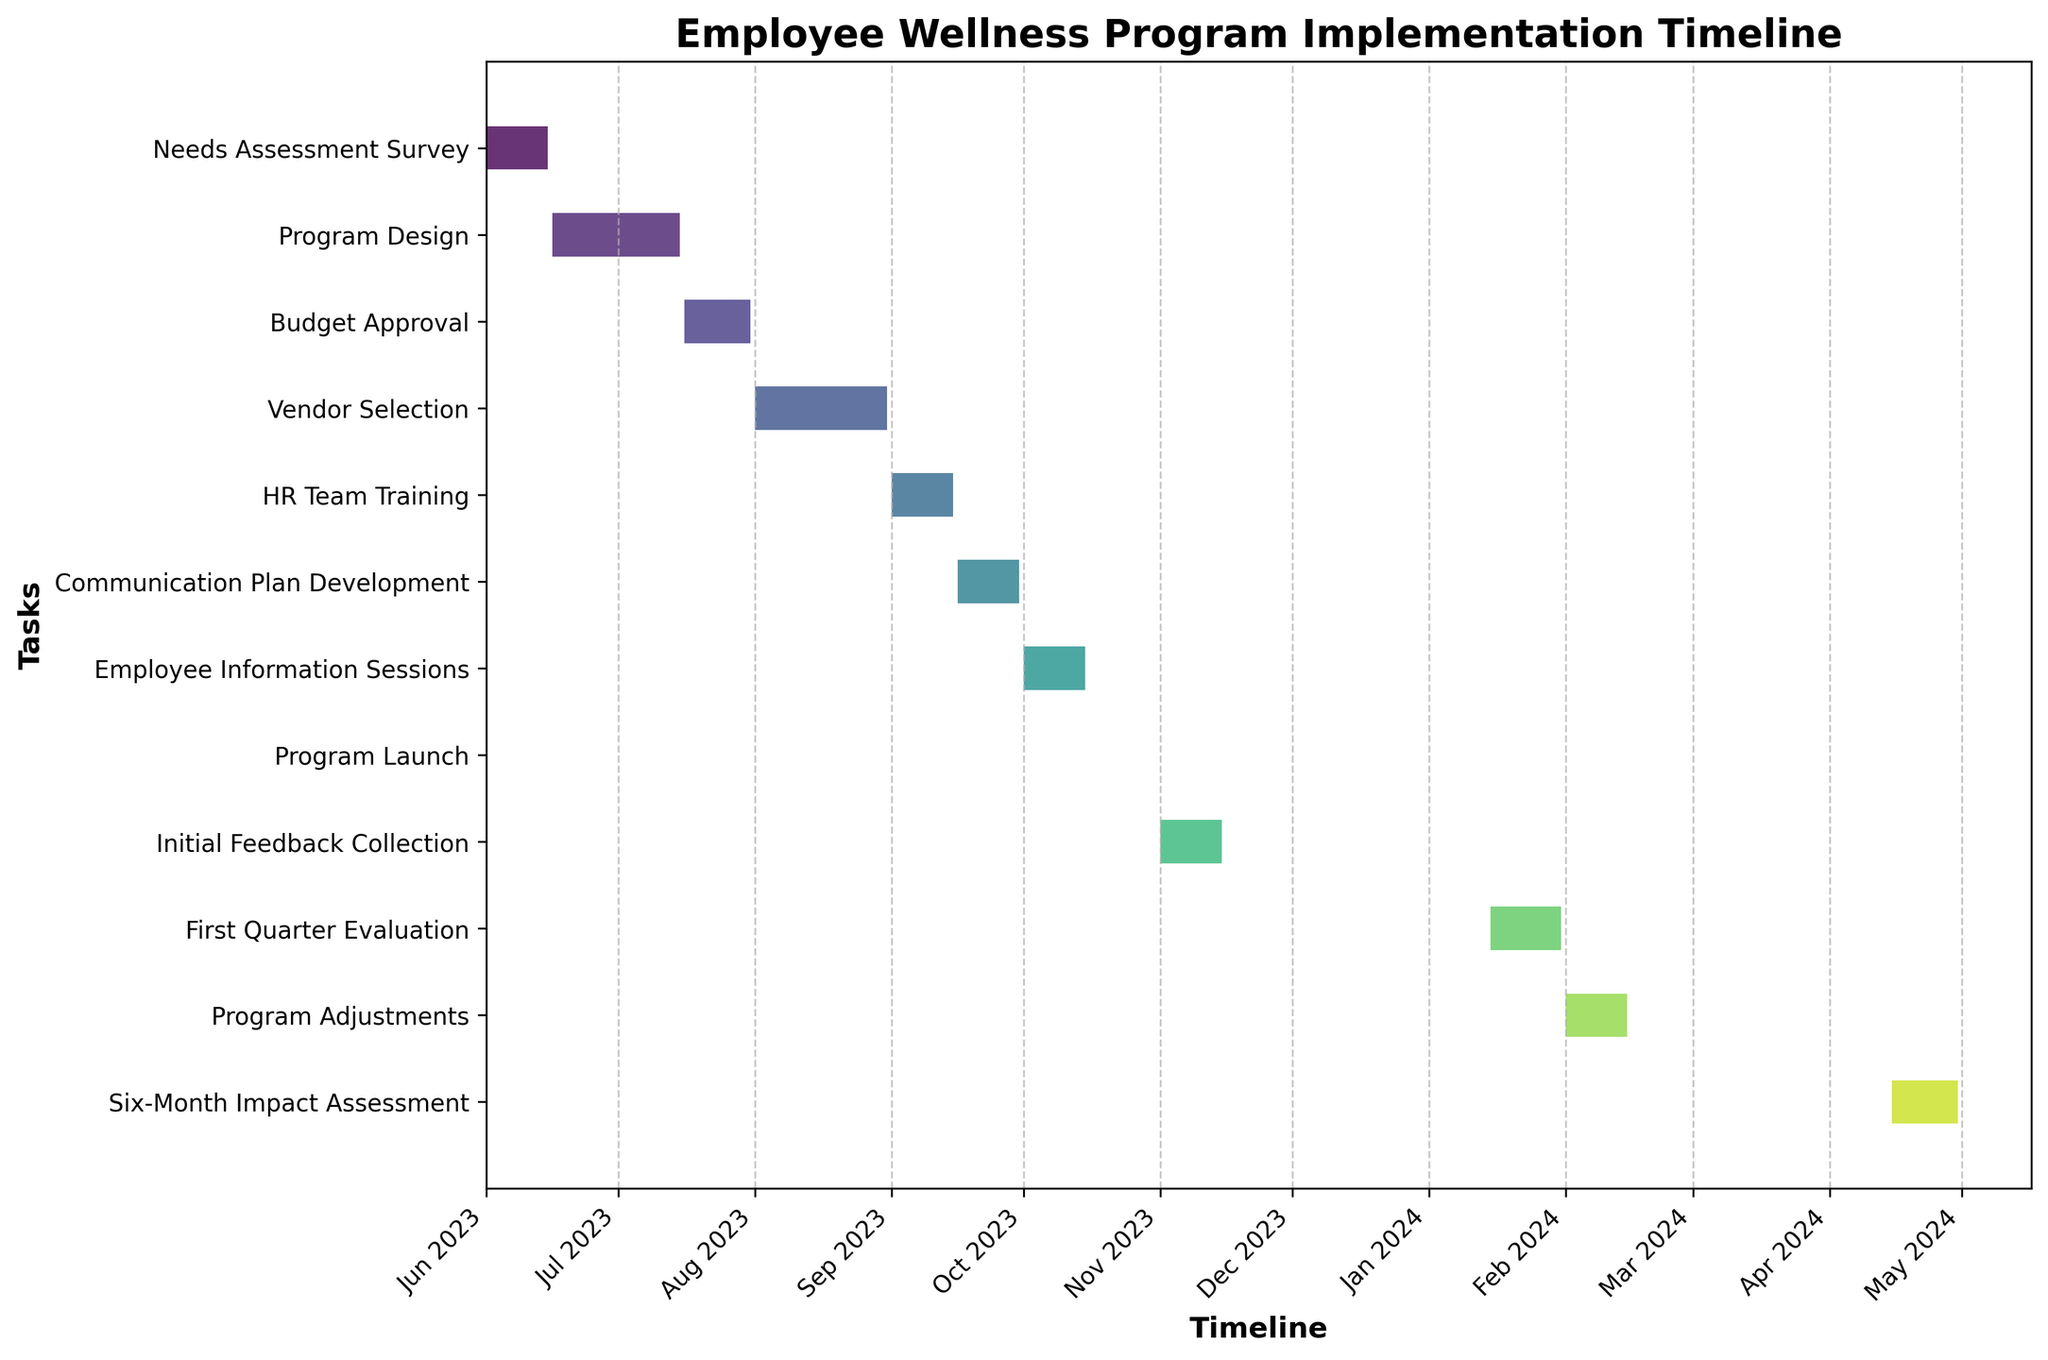How many tasks are there in total for the project timeline of the employee wellness program? Count the number of bars (tasks) shown on the y-axis in the Gantt chart.
Answer: 12 What is the title of the figure? Read the title at the top of the figure.
Answer: Employee Wellness Program Implementation Timeline Which task will take the longest to complete? Compare the lengths of all the bars representing each task and identify the longest one.
Answer: Vendor Selection During which month is the "Program Launch" task scheduled to occur? Locate the "Program Launch" task on the y-axis and see its corresponding timeline on the x-axis.
Answer: October 2023 How many tasks are scheduled to start in September 2023? Identify the tasks starting in September 2023 by checking the start dates on the timeline.
Answer: 2 How long is the "First Quarter Evaluation" phase compared to the "Needs Assessment Survey" phase? Calculate the duration (end date - start date) for each phase and compare the two. The "First Quarter Evaluation" runs from 2024-01-15 to 2024-01-31 (16 days), and the "Needs Assessment Survey" runs from 2023-06-01 to 2023-06-15 (14 days).
Answer: 2 days longer Which phase occurs immediately after the "Employee Information Sessions"? Identify the task on the y-axis that immediately follows the "Employee Information Sessions" task.
Answer: Program Launch Are there any overlapping tasks between October and November 2023? Check if any bars (tasks) have overlapping timelines within October and November 2023 on the x-axis.
Answer: No Which phase comes right before "Program Adjustments"? Determine the task that ends just before the start of "Program Adjustments" by looking at the y-axis order and the x-axis timeline.
Answer: First Quarter Evaluation How many distinct phases are planned for the project implementation? Count the unique bars representing tasks in the Gantt chart.
Answer: 12 